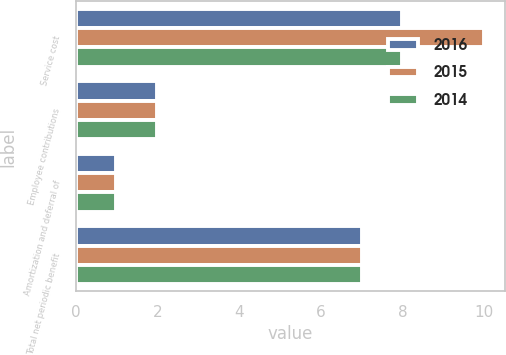Convert chart to OTSL. <chart><loc_0><loc_0><loc_500><loc_500><stacked_bar_chart><ecel><fcel>Service cost<fcel>Employee contributions<fcel>Amortization and deferral of<fcel>Total net periodic benefit<nl><fcel>2016<fcel>8<fcel>2<fcel>1<fcel>7<nl><fcel>2015<fcel>10<fcel>2<fcel>1<fcel>7<nl><fcel>2014<fcel>8<fcel>2<fcel>1<fcel>7<nl></chart> 